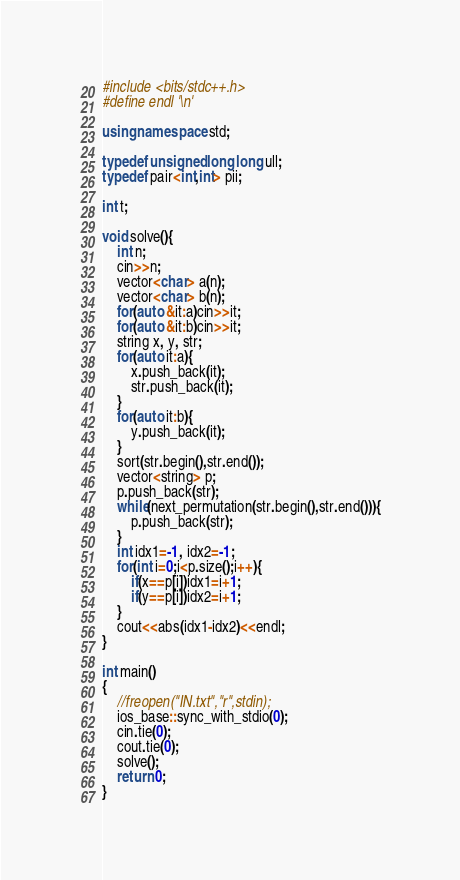Convert code to text. <code><loc_0><loc_0><loc_500><loc_500><_C++_>#include <bits/stdc++.h>
#define endl '\n'

using namespace std;

typedef unsigned long long ull;
typedef pair<int,int> pii;

int t;

void solve(){
    int n;
    cin>>n;
    vector<char> a(n);
    vector<char> b(n);
    for(auto &it:a)cin>>it;
    for(auto &it:b)cin>>it;
    string x, y, str;
    for(auto it:a){
        x.push_back(it);
        str.push_back(it);
    }
    for(auto it:b){
        y.push_back(it);
    }
    sort(str.begin(),str.end());
    vector<string> p;
    p.push_back(str);
    while(next_permutation(str.begin(),str.end())){
        p.push_back(str);
    }
    int idx1=-1, idx2=-1;
    for(int i=0;i<p.size();i++){
        if(x==p[i])idx1=i+1;
        if(y==p[i])idx2=i+1;
    }
    cout<<abs(idx1-idx2)<<endl;
}

int main()
{
    //freopen("IN.txt","r",stdin);
    ios_base::sync_with_stdio(0);
    cin.tie(0);
    cout.tie(0);
    solve();
    return 0;
}</code> 